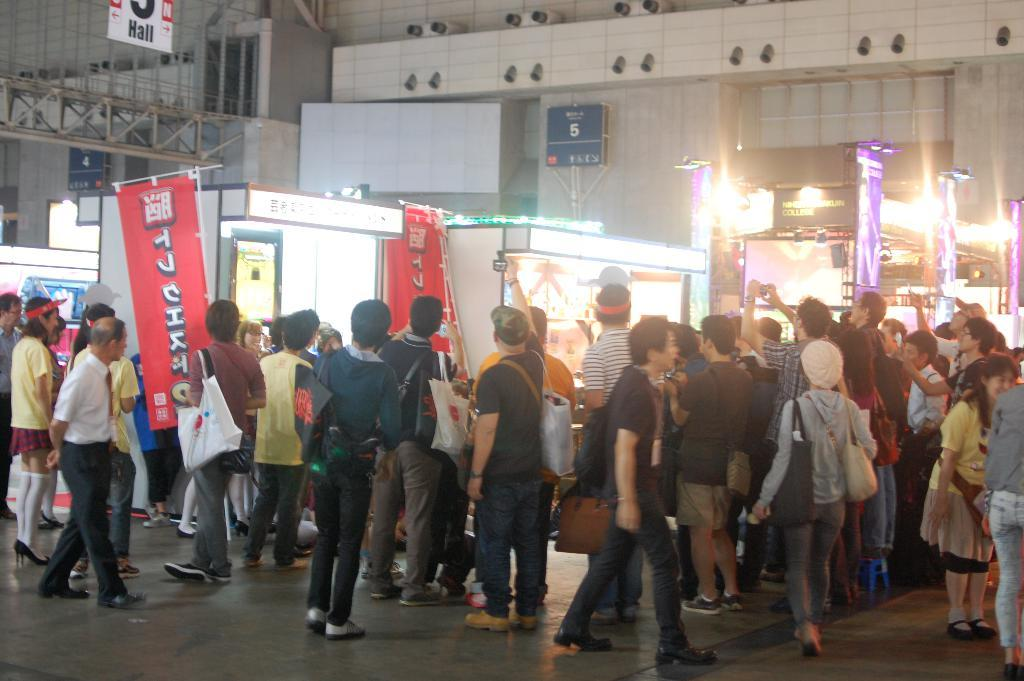What is the main subject in the foreground of the image? There is a crowd in the foreground of the image. Where is the crowd located? The crowd is on the road. What can be seen in the background of the image? There are tents, buildings, boards, lights, and metal rods in the background of the image. Can you describe the lighting conditions in the image? The image is likely taken during the night, as there are lights visible in the background. What type of quartz can be seen in the image? There is no quartz present in the image. Can you tell me how many zebras are in the crowd? There are no zebras in the image; it features a crowd of people. What family members can be seen in the image? The image does not depict any specific family members; it shows a crowd of people. 